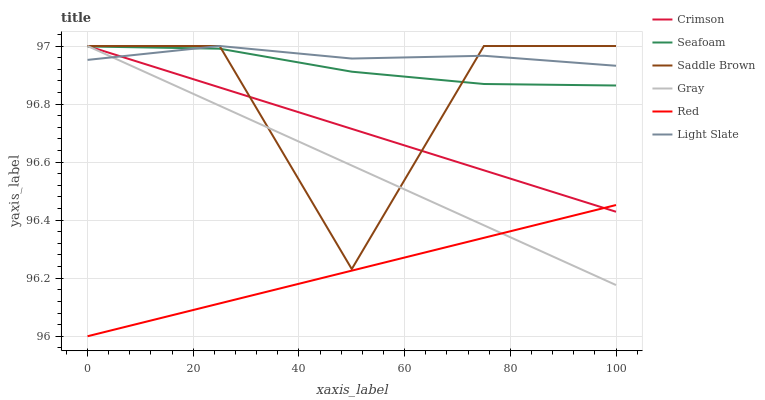Does Seafoam have the minimum area under the curve?
Answer yes or no. No. Does Seafoam have the maximum area under the curve?
Answer yes or no. No. Is Light Slate the smoothest?
Answer yes or no. No. Is Light Slate the roughest?
Answer yes or no. No. Does Seafoam have the lowest value?
Answer yes or no. No. Does Seafoam have the highest value?
Answer yes or no. No. Is Red less than Light Slate?
Answer yes or no. Yes. Is Light Slate greater than Red?
Answer yes or no. Yes. Does Red intersect Light Slate?
Answer yes or no. No. 